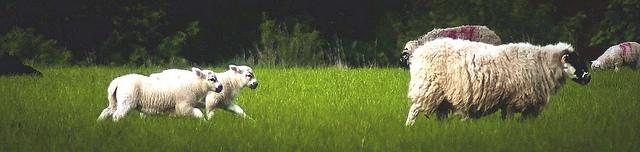How many goats are in the picture?
Short answer required. 0. Was this taken at a zoo?
Give a very brief answer. No. Is the baby sheep next to its mother?
Keep it brief. No. Are those for sale?
Give a very brief answer. No. Are the animals running?
Write a very short answer. Yes. 